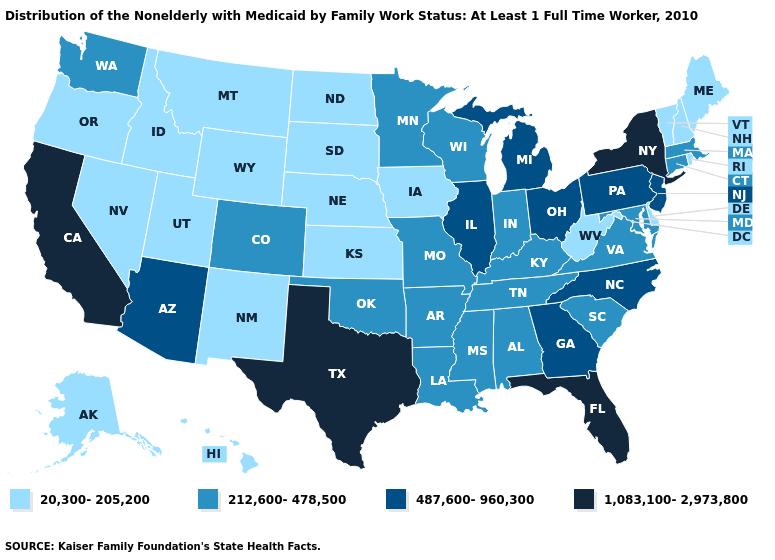Which states have the highest value in the USA?
Keep it brief. California, Florida, New York, Texas. What is the value of Alabama?
Keep it brief. 212,600-478,500. What is the highest value in states that border Arizona?
Answer briefly. 1,083,100-2,973,800. Does New York have the highest value in the Northeast?
Short answer required. Yes. What is the value of Colorado?
Quick response, please. 212,600-478,500. Among the states that border Indiana , which have the lowest value?
Quick response, please. Kentucky. Name the states that have a value in the range 1,083,100-2,973,800?
Short answer required. California, Florida, New York, Texas. Does South Carolina have a lower value than New Jersey?
Answer briefly. Yes. Name the states that have a value in the range 487,600-960,300?
Be succinct. Arizona, Georgia, Illinois, Michigan, New Jersey, North Carolina, Ohio, Pennsylvania. Which states hav the highest value in the Northeast?
Concise answer only. New York. Which states have the lowest value in the USA?
Answer briefly. Alaska, Delaware, Hawaii, Idaho, Iowa, Kansas, Maine, Montana, Nebraska, Nevada, New Hampshire, New Mexico, North Dakota, Oregon, Rhode Island, South Dakota, Utah, Vermont, West Virginia, Wyoming. Name the states that have a value in the range 1,083,100-2,973,800?
Answer briefly. California, Florida, New York, Texas. Name the states that have a value in the range 212,600-478,500?
Short answer required. Alabama, Arkansas, Colorado, Connecticut, Indiana, Kentucky, Louisiana, Maryland, Massachusetts, Minnesota, Mississippi, Missouri, Oklahoma, South Carolina, Tennessee, Virginia, Washington, Wisconsin. What is the value of Wyoming?
Keep it brief. 20,300-205,200. Name the states that have a value in the range 487,600-960,300?
Be succinct. Arizona, Georgia, Illinois, Michigan, New Jersey, North Carolina, Ohio, Pennsylvania. 